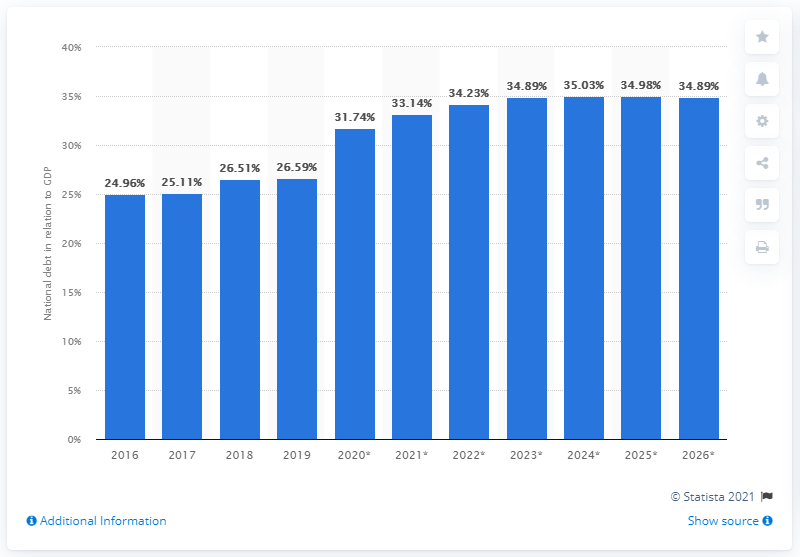Draw attention to some important aspects in this diagram. In 2019, the national debt of Guatemala constituted approximately 26.59% of the country's Gross Domestic Product (GDP). 